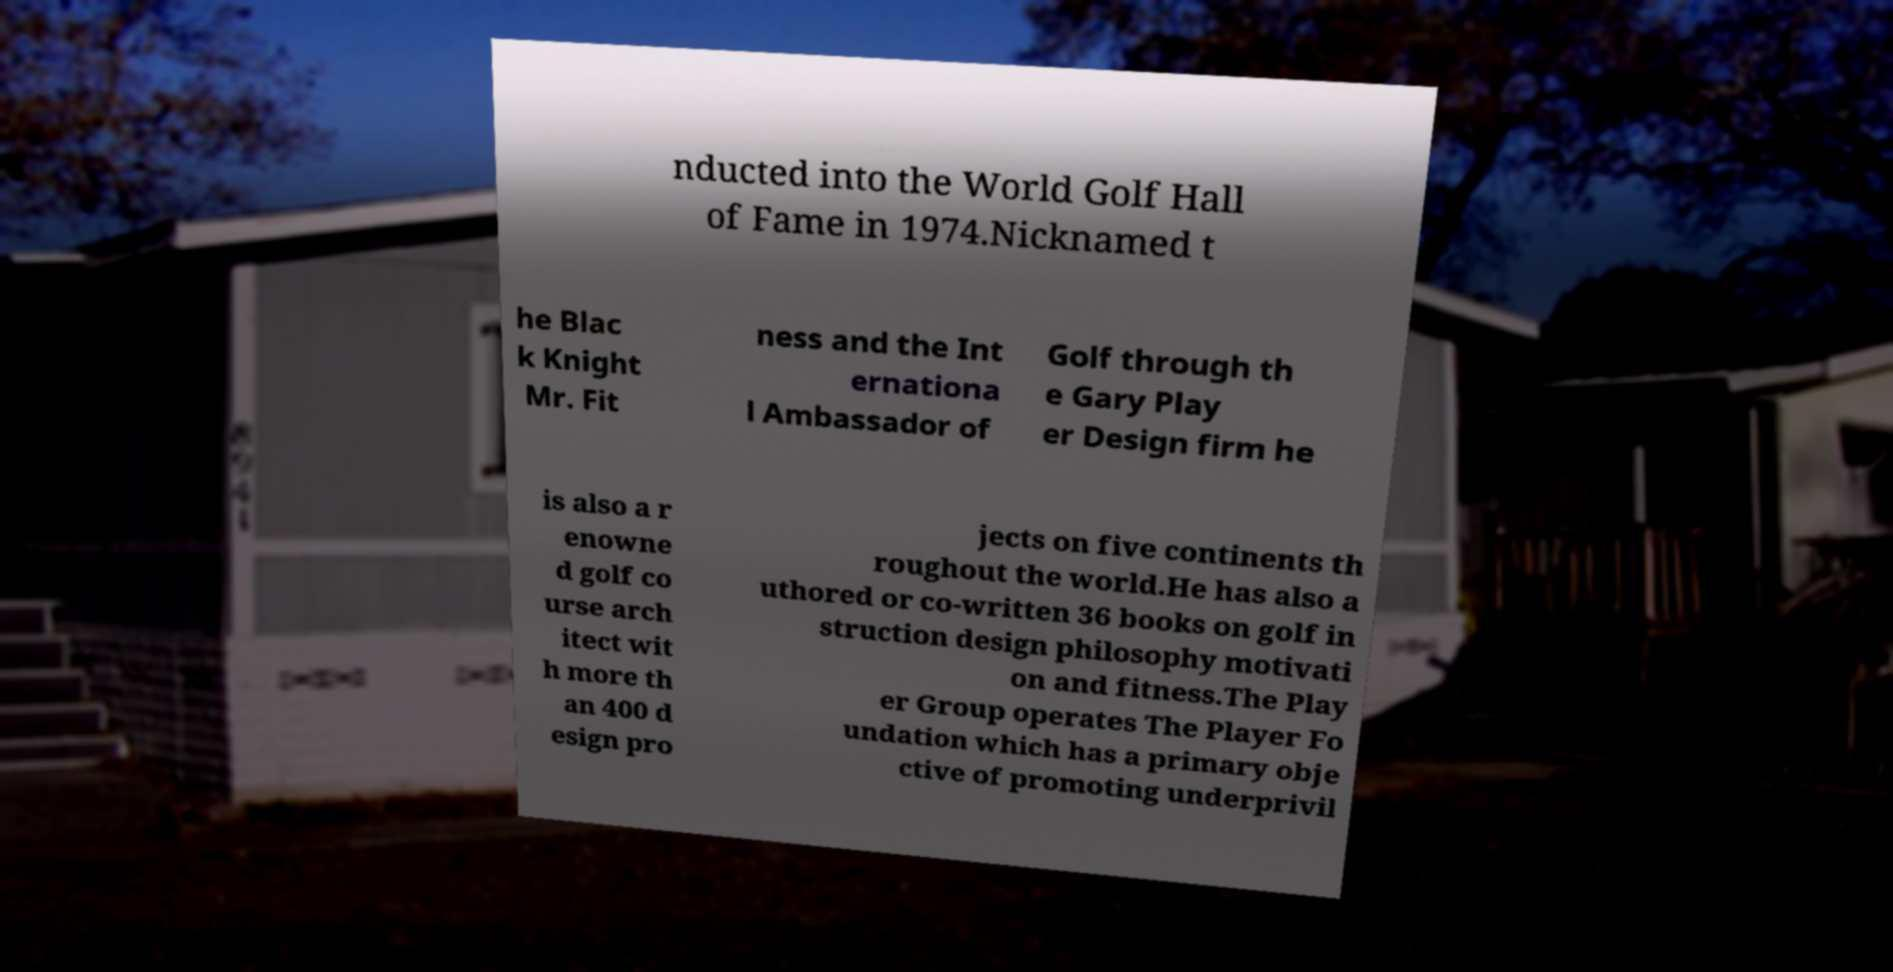What messages or text are displayed in this image? I need them in a readable, typed format. nducted into the World Golf Hall of Fame in 1974.Nicknamed t he Blac k Knight Mr. Fit ness and the Int ernationa l Ambassador of Golf through th e Gary Play er Design firm he is also a r enowne d golf co urse arch itect wit h more th an 400 d esign pro jects on five continents th roughout the world.He has also a uthored or co-written 36 books on golf in struction design philosophy motivati on and fitness.The Play er Group operates The Player Fo undation which has a primary obje ctive of promoting underprivil 